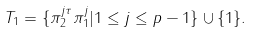<formula> <loc_0><loc_0><loc_500><loc_500>T _ { 1 } = \{ \pi _ { 2 } ^ { j \tau } \pi _ { 1 } ^ { j } | 1 \leq j \leq p - 1 \} \cup \{ 1 \} .</formula> 